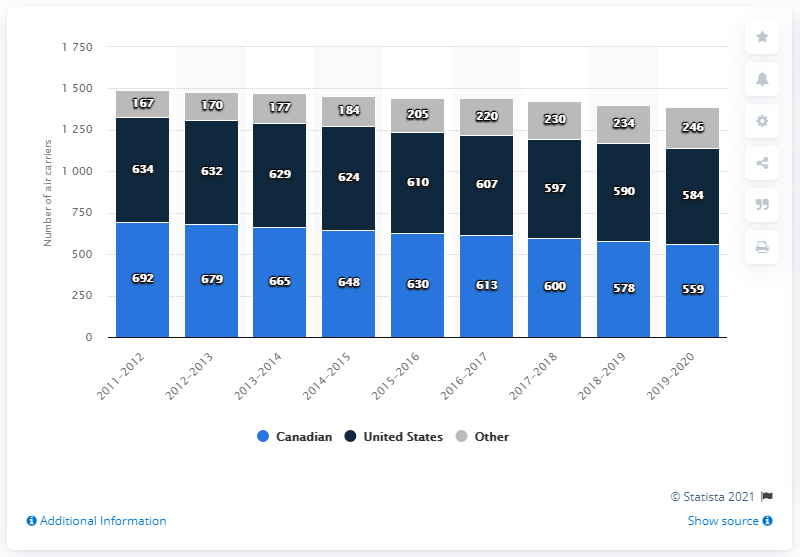Identify some key points in this picture. In 2020, there were 584 U.S. air carriers that held licenses to operate in Canada. 